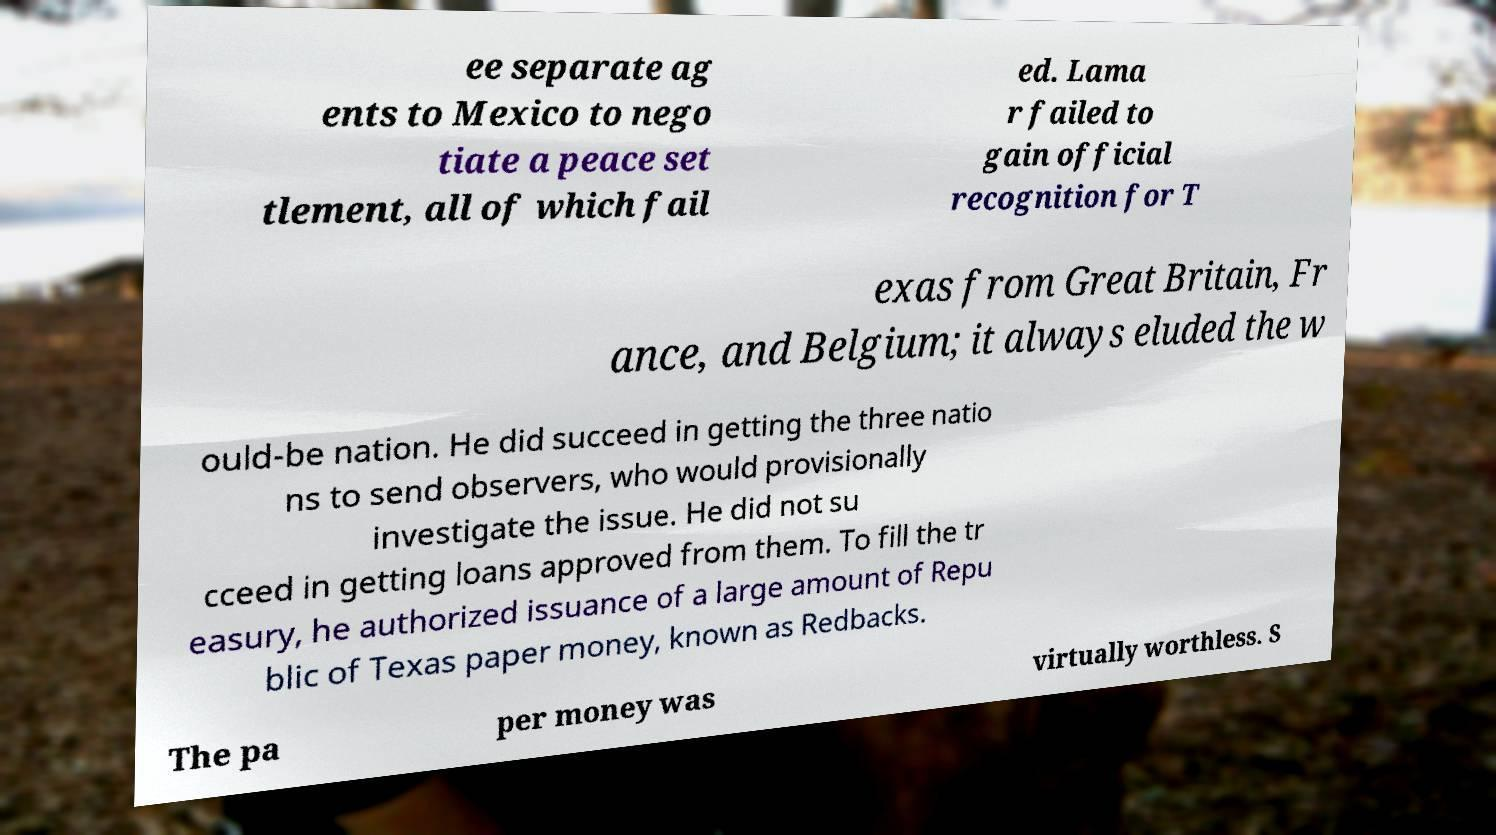Can you read and provide the text displayed in the image?This photo seems to have some interesting text. Can you extract and type it out for me? ee separate ag ents to Mexico to nego tiate a peace set tlement, all of which fail ed. Lama r failed to gain official recognition for T exas from Great Britain, Fr ance, and Belgium; it always eluded the w ould-be nation. He did succeed in getting the three natio ns to send observers, who would provisionally investigate the issue. He did not su cceed in getting loans approved from them. To fill the tr easury, he authorized issuance of a large amount of Repu blic of Texas paper money, known as Redbacks. The pa per money was virtually worthless. S 